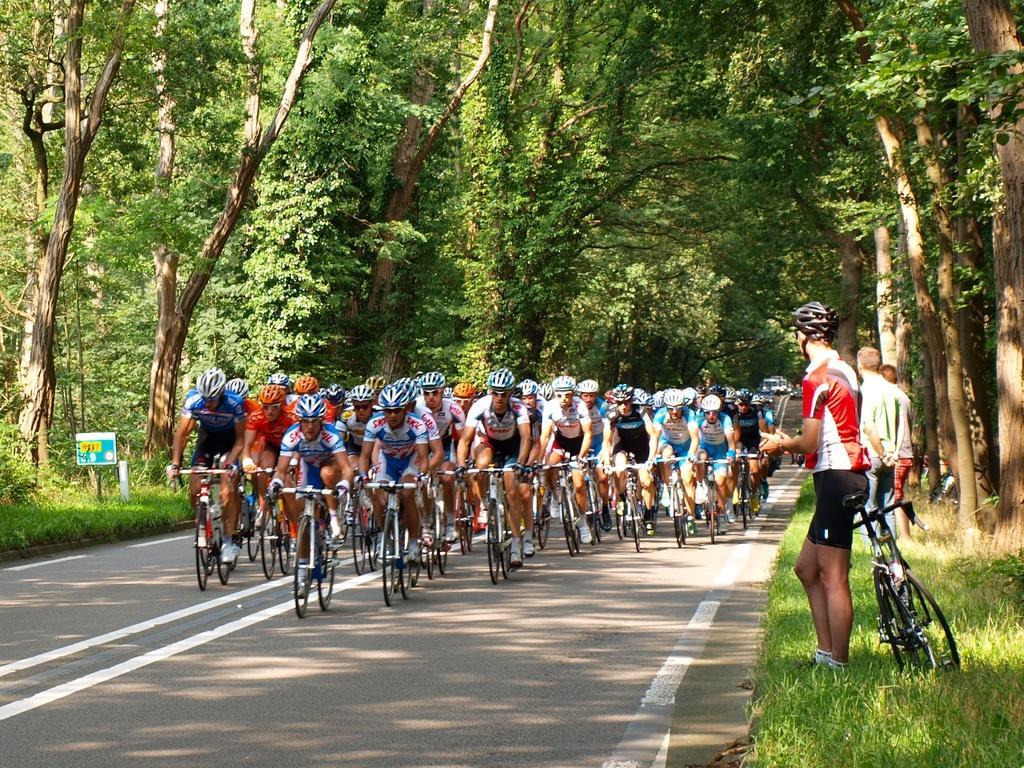Please provide a concise description of this image. The image is taken on the road. There are people riding bicycles on the road. On the right there are people standing. There is a bicycle. In the background there are trees. 